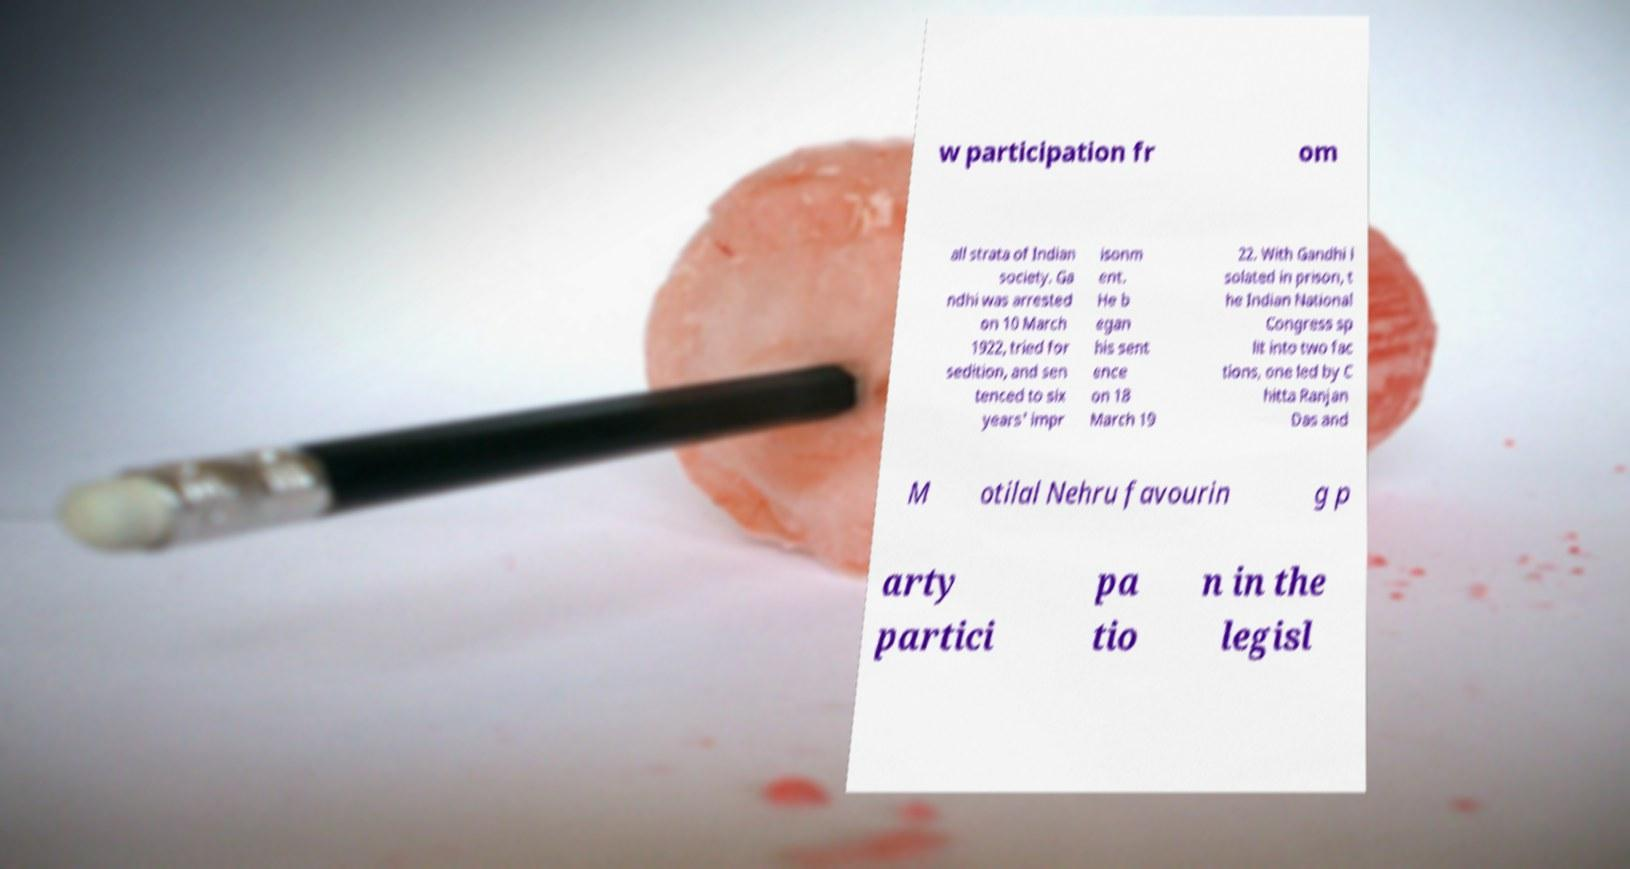Could you assist in decoding the text presented in this image and type it out clearly? w participation fr om all strata of Indian society. Ga ndhi was arrested on 10 March 1922, tried for sedition, and sen tenced to six years' impr isonm ent. He b egan his sent ence on 18 March 19 22. With Gandhi i solated in prison, t he Indian National Congress sp lit into two fac tions, one led by C hitta Ranjan Das and M otilal Nehru favourin g p arty partici pa tio n in the legisl 